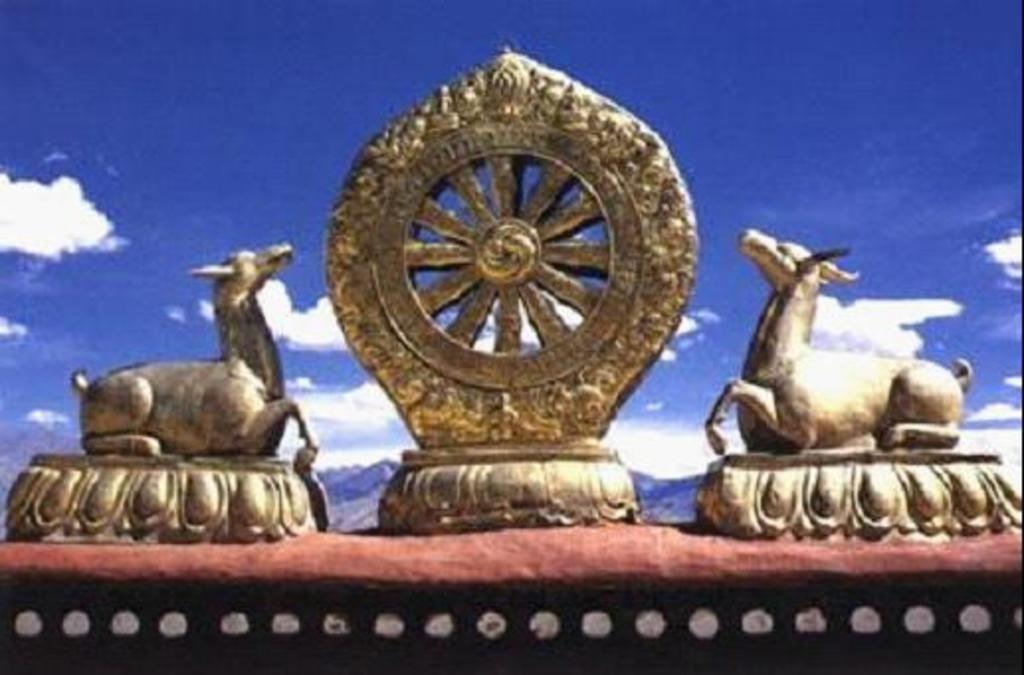What is the main subject in the center of the image? There are statues ines in the center of the image. What can be seen in the background of the image? Sky, clouds, and mountains are visible in the background of the image. How many clocks are hanging from the fingers of the statues in the image? There are no clocks or fingers visible in the image; it features statues and a background with sky, clouds, and mountains. 